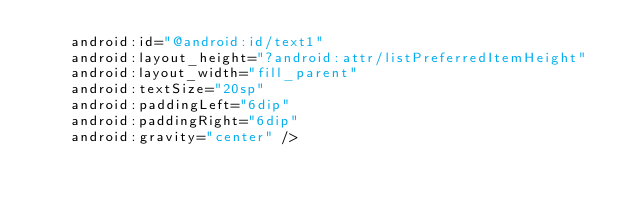Convert code to text. <code><loc_0><loc_0><loc_500><loc_500><_XML_>    android:id="@android:id/text1"
    android:layout_height="?android:attr/listPreferredItemHeight"
    android:layout_width="fill_parent"
    android:textSize="20sp"
    android:paddingLeft="6dip"
    android:paddingRight="6dip"
    android:gravity="center" /></code> 